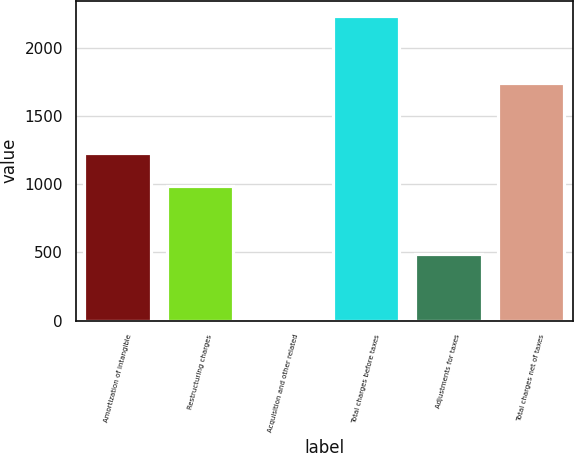Convert chart. <chart><loc_0><loc_0><loc_500><loc_500><bar_chart><fcel>Amortization of intangible<fcel>Restructuring charges<fcel>Acquisition and other related<fcel>Total charges before taxes<fcel>Adjustments for taxes<fcel>Total charges net of taxes<nl><fcel>1228<fcel>983<fcel>21<fcel>2232<fcel>490<fcel>1742<nl></chart> 